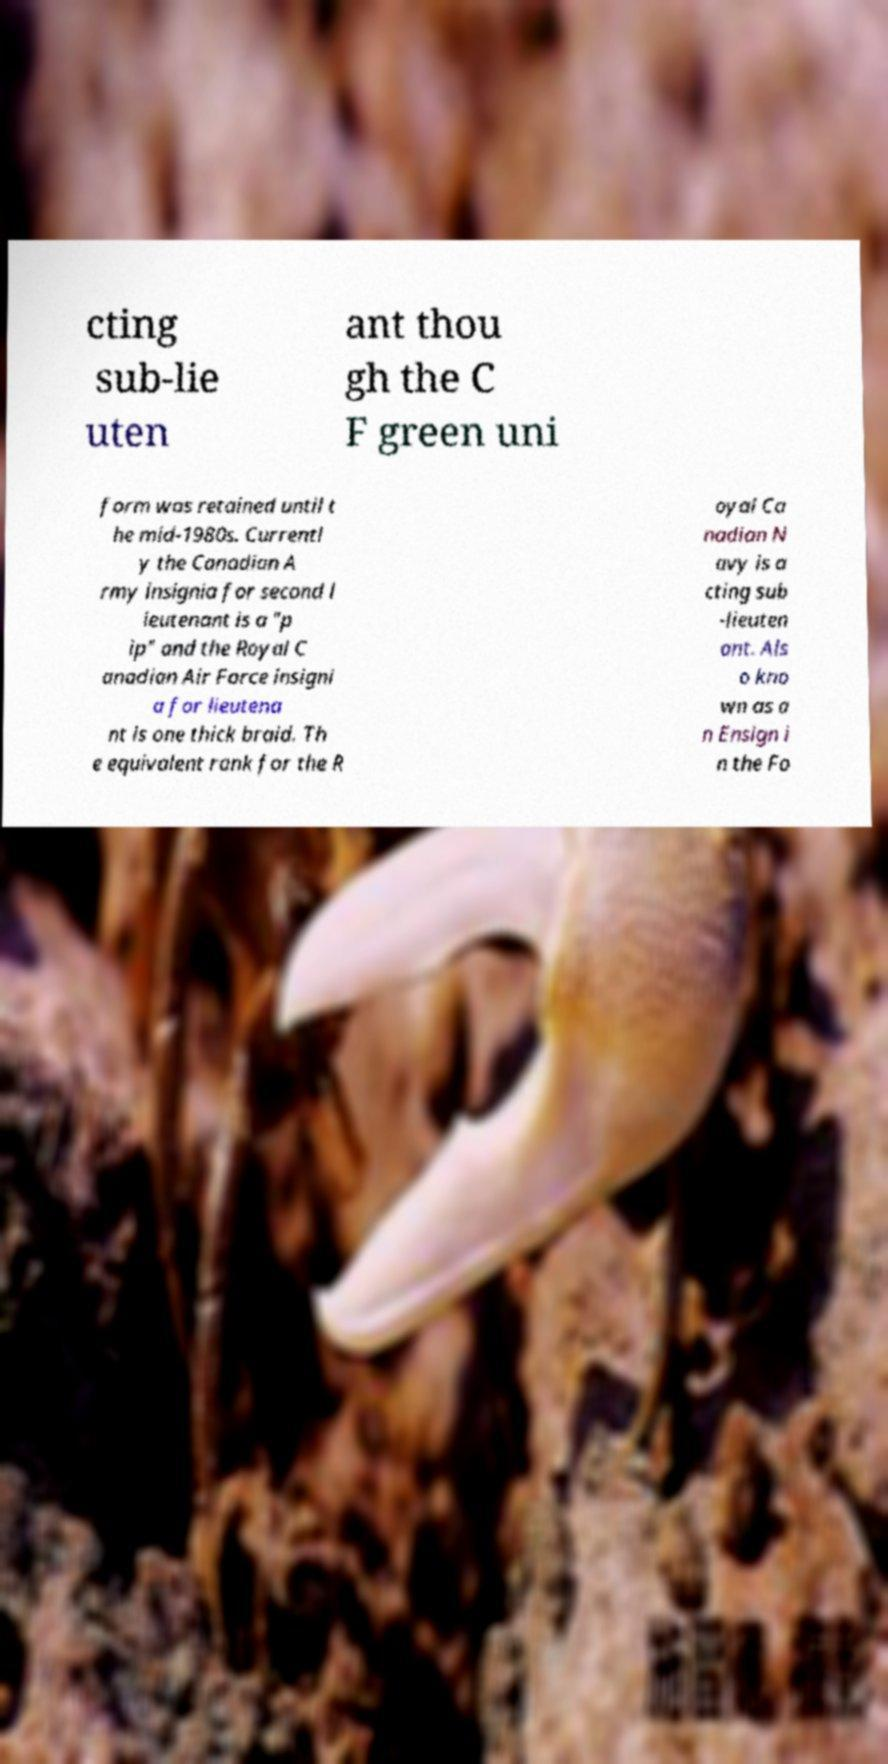Could you extract and type out the text from this image? cting sub-lie uten ant thou gh the C F green uni form was retained until t he mid-1980s. Currentl y the Canadian A rmy insignia for second l ieutenant is a "p ip" and the Royal C anadian Air Force insigni a for lieutena nt is one thick braid. Th e equivalent rank for the R oyal Ca nadian N avy is a cting sub -lieuten ant. Als o kno wn as a n Ensign i n the Fo 